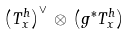<formula> <loc_0><loc_0><loc_500><loc_500>\left ( T ^ { h } _ { x } \right ) ^ { \vee } \, \otimes \, \left ( g ^ { * } T ^ { h } _ { x } \right )</formula> 